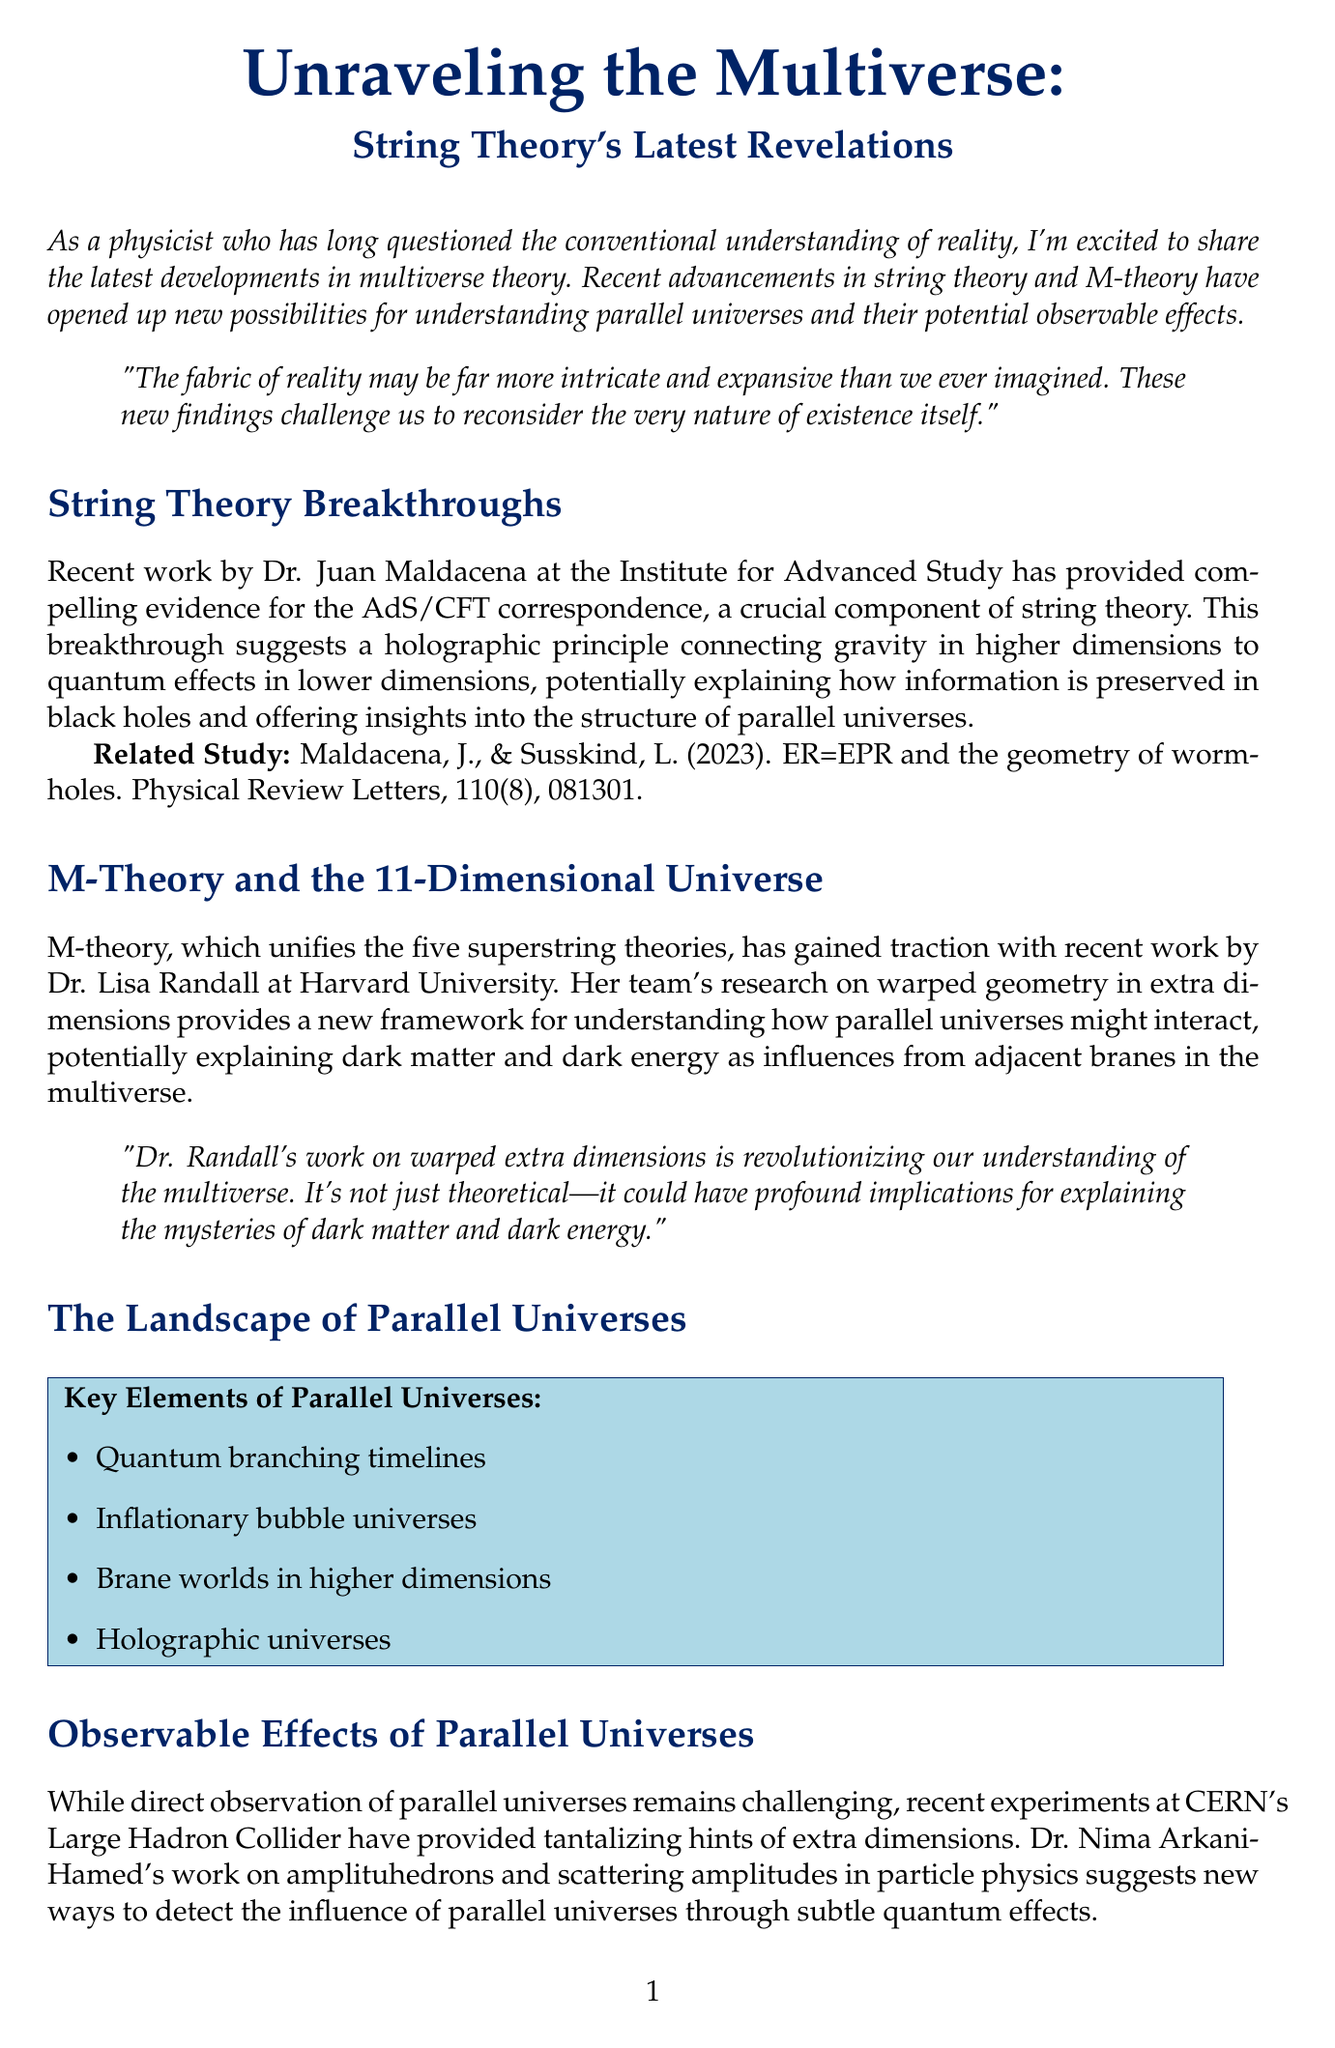What is the title of the newsletter? The title is the main heading of the newsletter document.
Answer: Unraveling the Multiverse: String Theory's Latest Revelations Who provided evidence for the AdS/CFT correspondence? This refers to the researcher mentioned in the first section of the document.
Answer: Dr. Juan Maldacena What is one of the potential observables of parallel universes mentioned? The question refers to the specific examples listed in the section on observable effects.
Answer: Gravitational wave echoes from colliding branes How many dimensions does M-theory involve? This information is given in the section discussing M-theory.
Answer: 11-Dimensional Who is the author of the newsletter? This refers to the person named in the last section about the author.
Answer: Dr. Evelyn Caldwell Which experiment is featured for detecting gravitational waves? The question targets the specific experiments mentioned for detection purposes.
Answer: LIGO gravitational wave observatory What major theory connects parallel universes and quantum mechanics? This relates to the theoretical framework discussed throughout the newsletter.
Answer: String Theory What year was the related study by Maldacena and Susskind published? This asks for the publication year of the study cited in the document.
Answer: 2023 